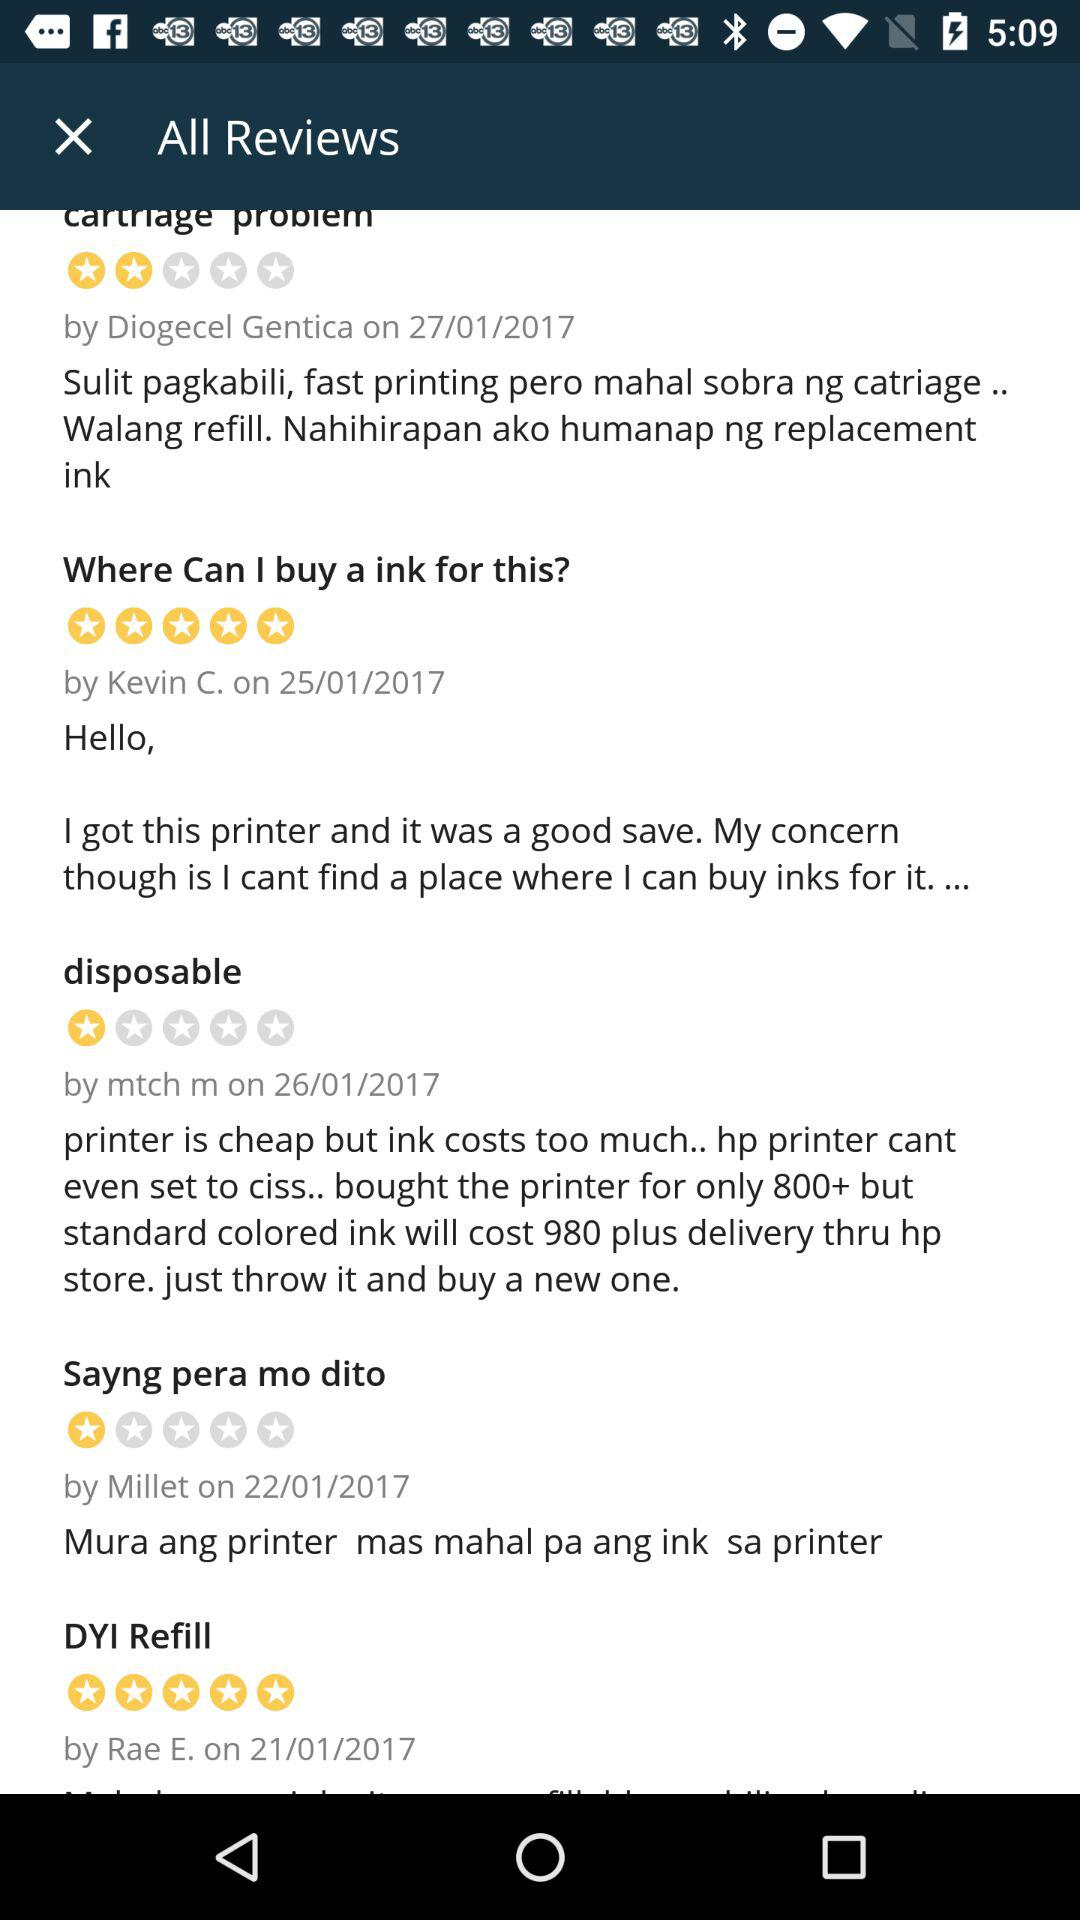On which date did Kevin C. post his review? Kevin C. posted his review on January 25, 2017. 